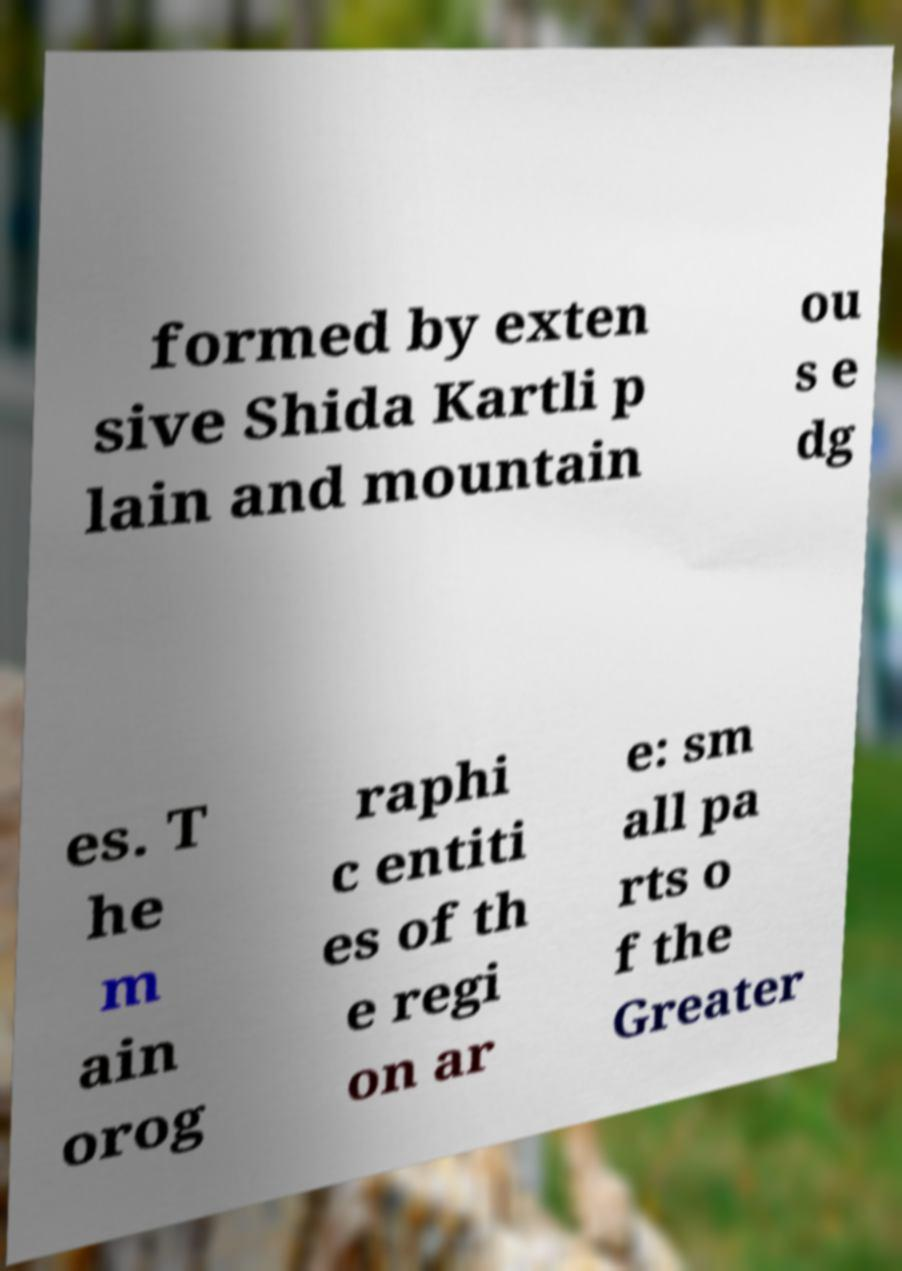Could you extract and type out the text from this image? formed by exten sive Shida Kartli p lain and mountain ou s e dg es. T he m ain orog raphi c entiti es of th e regi on ar e: sm all pa rts o f the Greater 